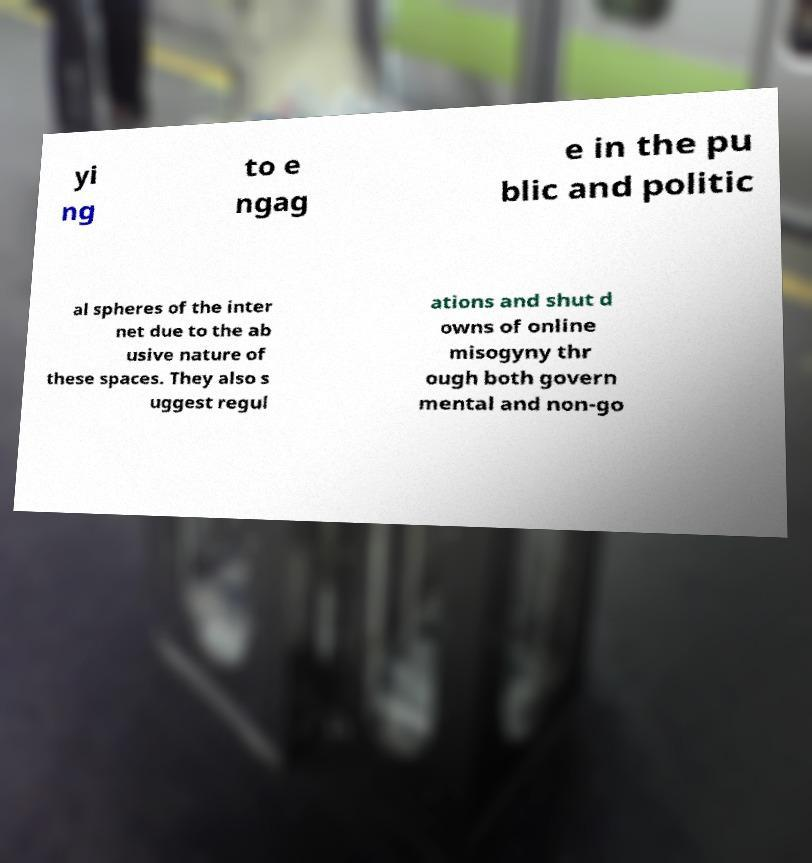There's text embedded in this image that I need extracted. Can you transcribe it verbatim? yi ng to e ngag e in the pu blic and politic al spheres of the inter net due to the ab usive nature of these spaces. They also s uggest regul ations and shut d owns of online misogyny thr ough both govern mental and non-go 